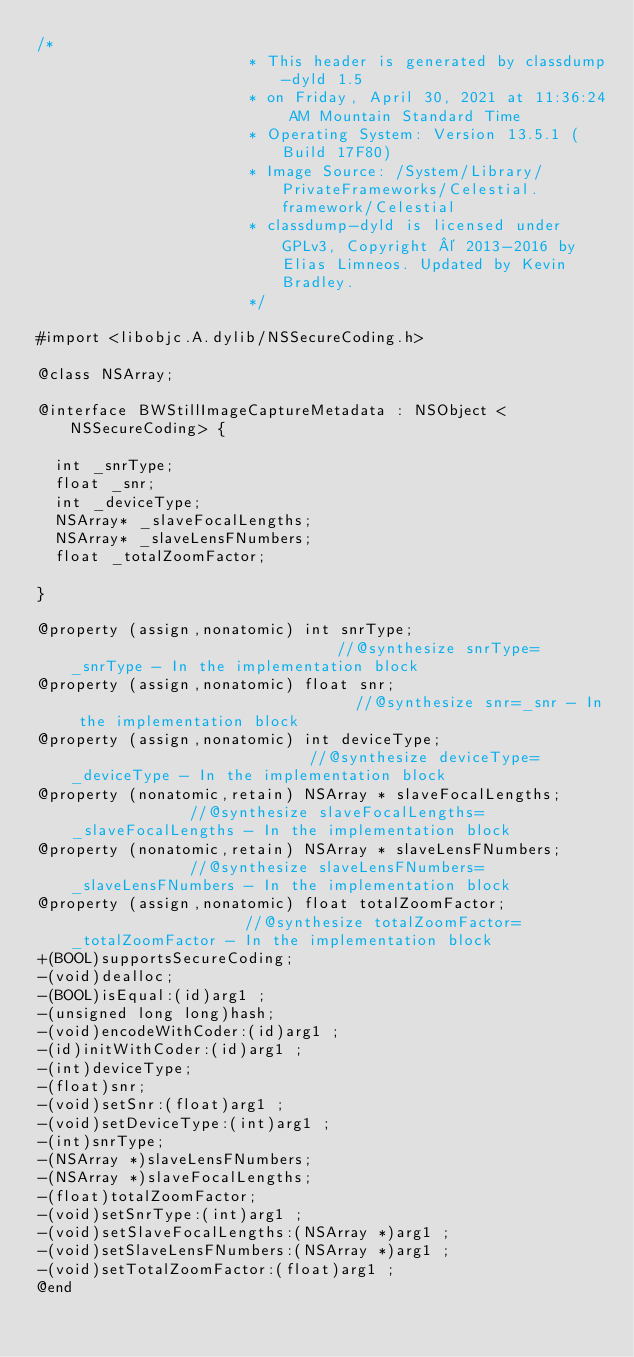<code> <loc_0><loc_0><loc_500><loc_500><_C_>/*
                       * This header is generated by classdump-dyld 1.5
                       * on Friday, April 30, 2021 at 11:36:24 AM Mountain Standard Time
                       * Operating System: Version 13.5.1 (Build 17F80)
                       * Image Source: /System/Library/PrivateFrameworks/Celestial.framework/Celestial
                       * classdump-dyld is licensed under GPLv3, Copyright © 2013-2016 by Elias Limneos. Updated by Kevin Bradley.
                       */

#import <libobjc.A.dylib/NSSecureCoding.h>

@class NSArray;

@interface BWStillImageCaptureMetadata : NSObject <NSSecureCoding> {

	int _snrType;
	float _snr;
	int _deviceType;
	NSArray* _slaveFocalLengths;
	NSArray* _slaveLensFNumbers;
	float _totalZoomFactor;

}

@property (assign,nonatomic) int snrType;                              //@synthesize snrType=_snrType - In the implementation block
@property (assign,nonatomic) float snr;                                //@synthesize snr=_snr - In the implementation block
@property (assign,nonatomic) int deviceType;                           //@synthesize deviceType=_deviceType - In the implementation block
@property (nonatomic,retain) NSArray * slaveFocalLengths;              //@synthesize slaveFocalLengths=_slaveFocalLengths - In the implementation block
@property (nonatomic,retain) NSArray * slaveLensFNumbers;              //@synthesize slaveLensFNumbers=_slaveLensFNumbers - In the implementation block
@property (assign,nonatomic) float totalZoomFactor;                    //@synthesize totalZoomFactor=_totalZoomFactor - In the implementation block
+(BOOL)supportsSecureCoding;
-(void)dealloc;
-(BOOL)isEqual:(id)arg1 ;
-(unsigned long long)hash;
-(void)encodeWithCoder:(id)arg1 ;
-(id)initWithCoder:(id)arg1 ;
-(int)deviceType;
-(float)snr;
-(void)setSnr:(float)arg1 ;
-(void)setDeviceType:(int)arg1 ;
-(int)snrType;
-(NSArray *)slaveLensFNumbers;
-(NSArray *)slaveFocalLengths;
-(float)totalZoomFactor;
-(void)setSnrType:(int)arg1 ;
-(void)setSlaveFocalLengths:(NSArray *)arg1 ;
-(void)setSlaveLensFNumbers:(NSArray *)arg1 ;
-(void)setTotalZoomFactor:(float)arg1 ;
@end

</code> 